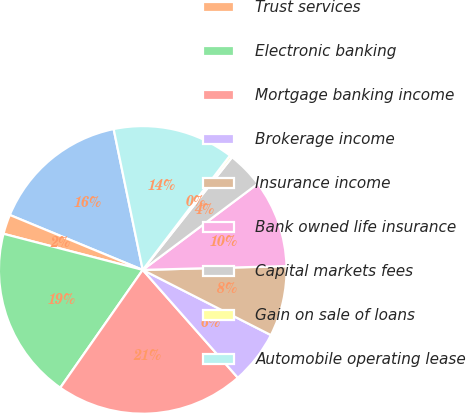<chart> <loc_0><loc_0><loc_500><loc_500><pie_chart><fcel>Service charges on deposit<fcel>Trust services<fcel>Electronic banking<fcel>Mortgage banking income<fcel>Brokerage income<fcel>Insurance income<fcel>Bank owned life insurance<fcel>Capital markets fees<fcel>Gain on sale of loans<fcel>Automobile operating lease<nl><fcel>15.52%<fcel>2.2%<fcel>19.32%<fcel>21.22%<fcel>6.01%<fcel>7.91%<fcel>9.81%<fcel>4.1%<fcel>0.3%<fcel>13.61%<nl></chart> 